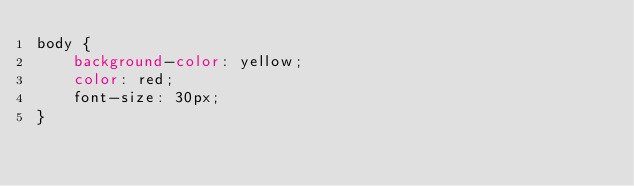Convert code to text. <code><loc_0><loc_0><loc_500><loc_500><_CSS_>body {
    background-color: yellow;
    color: red;
    font-size: 30px;
}</code> 